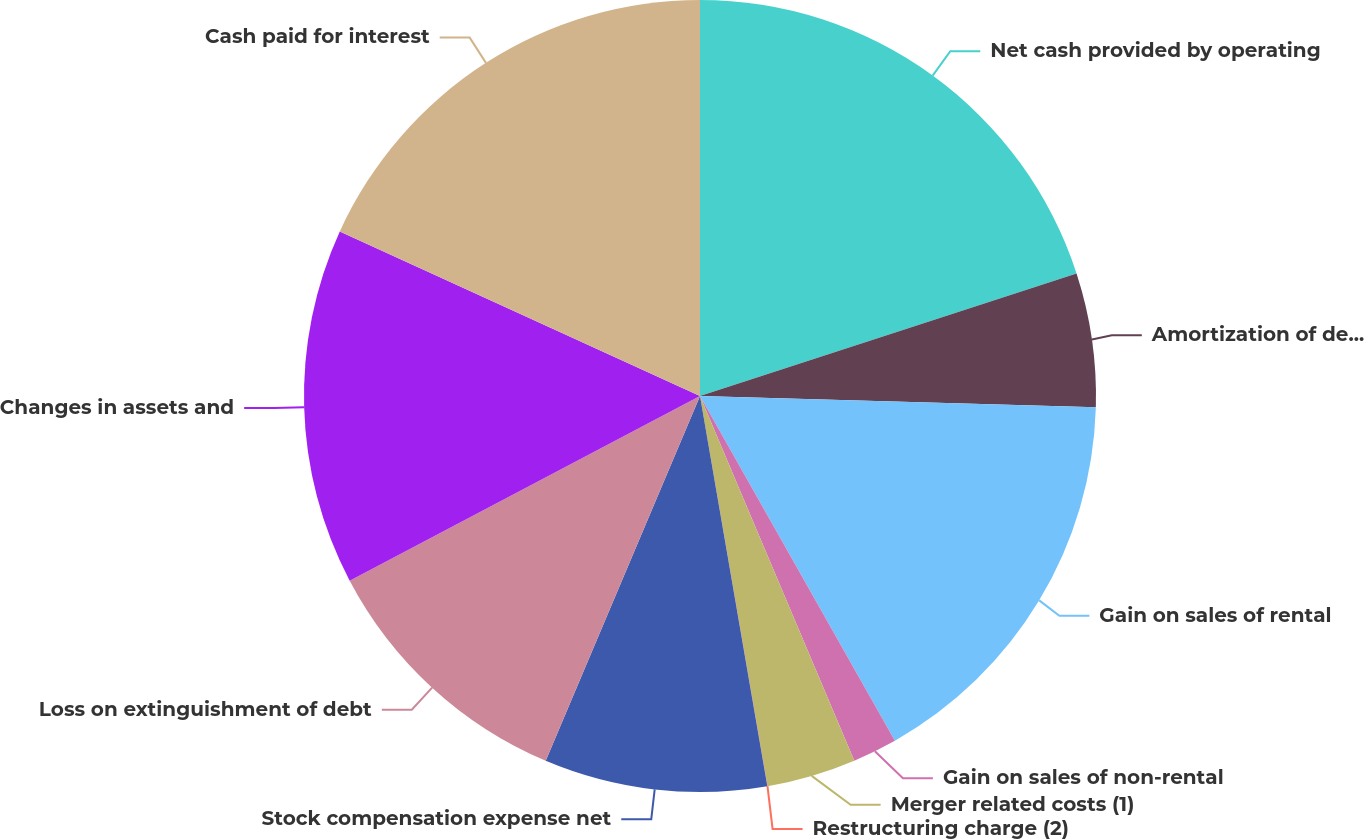Convert chart to OTSL. <chart><loc_0><loc_0><loc_500><loc_500><pie_chart><fcel>Net cash provided by operating<fcel>Amortization of deferred<fcel>Gain on sales of rental<fcel>Gain on sales of non-rental<fcel>Merger related costs (1)<fcel>Restructuring charge (2)<fcel>Stock compensation expense net<fcel>Loss on extinguishment of debt<fcel>Changes in assets and<fcel>Cash paid for interest<nl><fcel>19.99%<fcel>5.46%<fcel>16.36%<fcel>1.82%<fcel>3.64%<fcel>0.01%<fcel>9.09%<fcel>10.91%<fcel>14.54%<fcel>18.18%<nl></chart> 